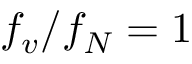Convert formula to latex. <formula><loc_0><loc_0><loc_500><loc_500>f _ { v } / f _ { N } = 1</formula> 